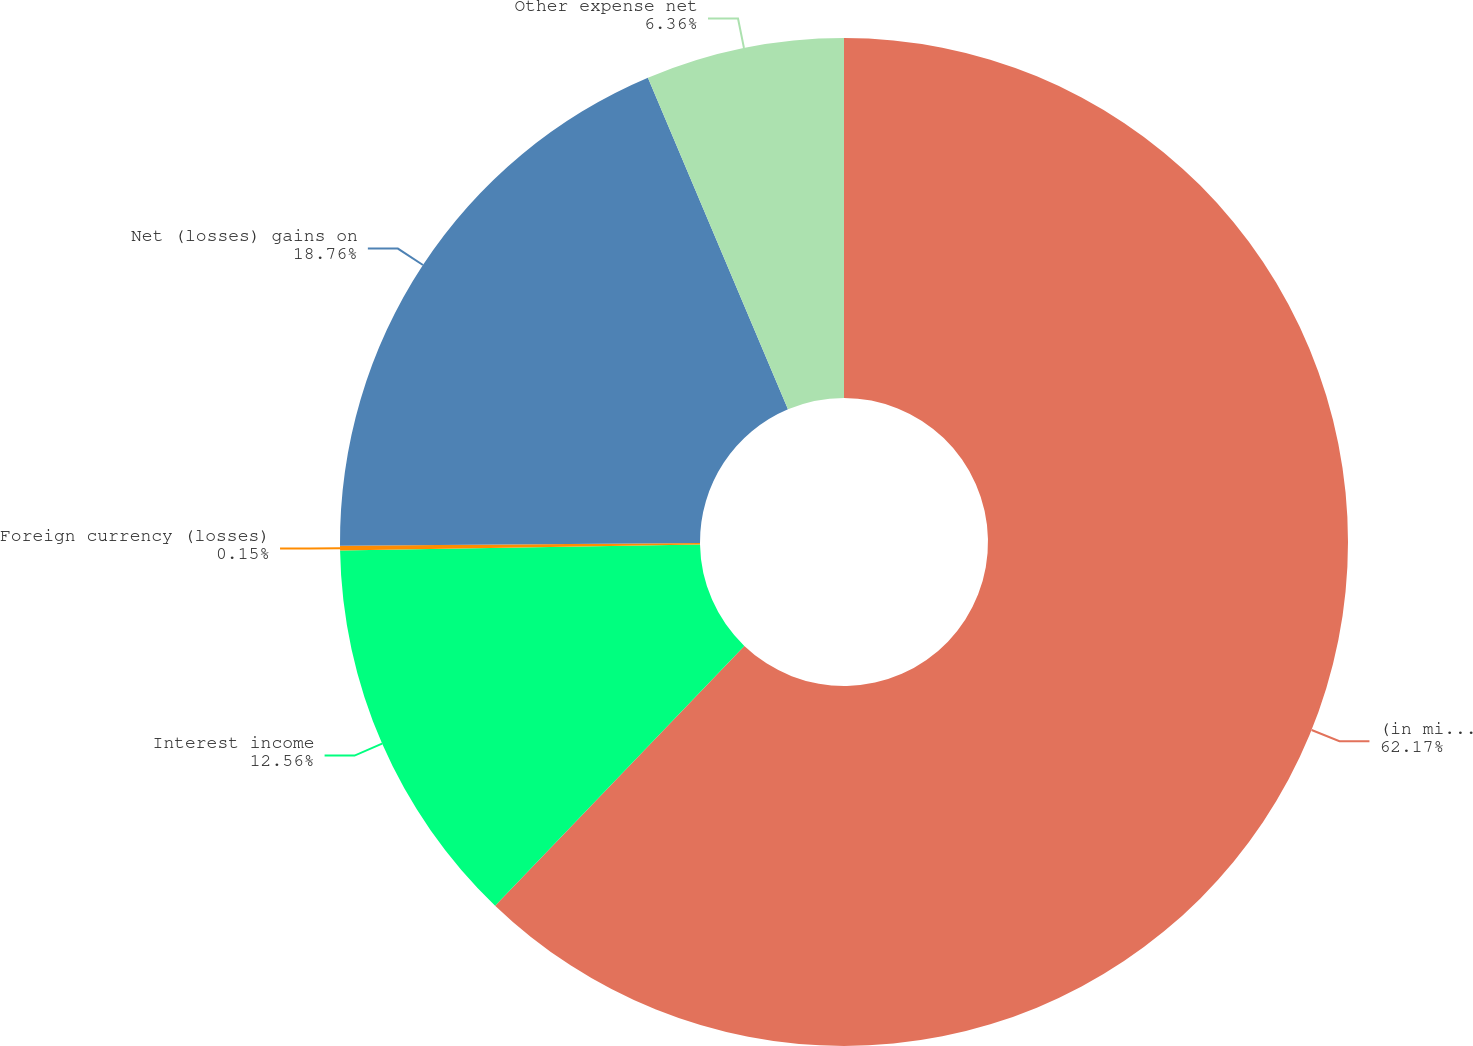<chart> <loc_0><loc_0><loc_500><loc_500><pie_chart><fcel>(in millions)<fcel>Interest income<fcel>Foreign currency (losses)<fcel>Net (losses) gains on<fcel>Other expense net<nl><fcel>62.17%<fcel>12.56%<fcel>0.15%<fcel>18.76%<fcel>6.36%<nl></chart> 